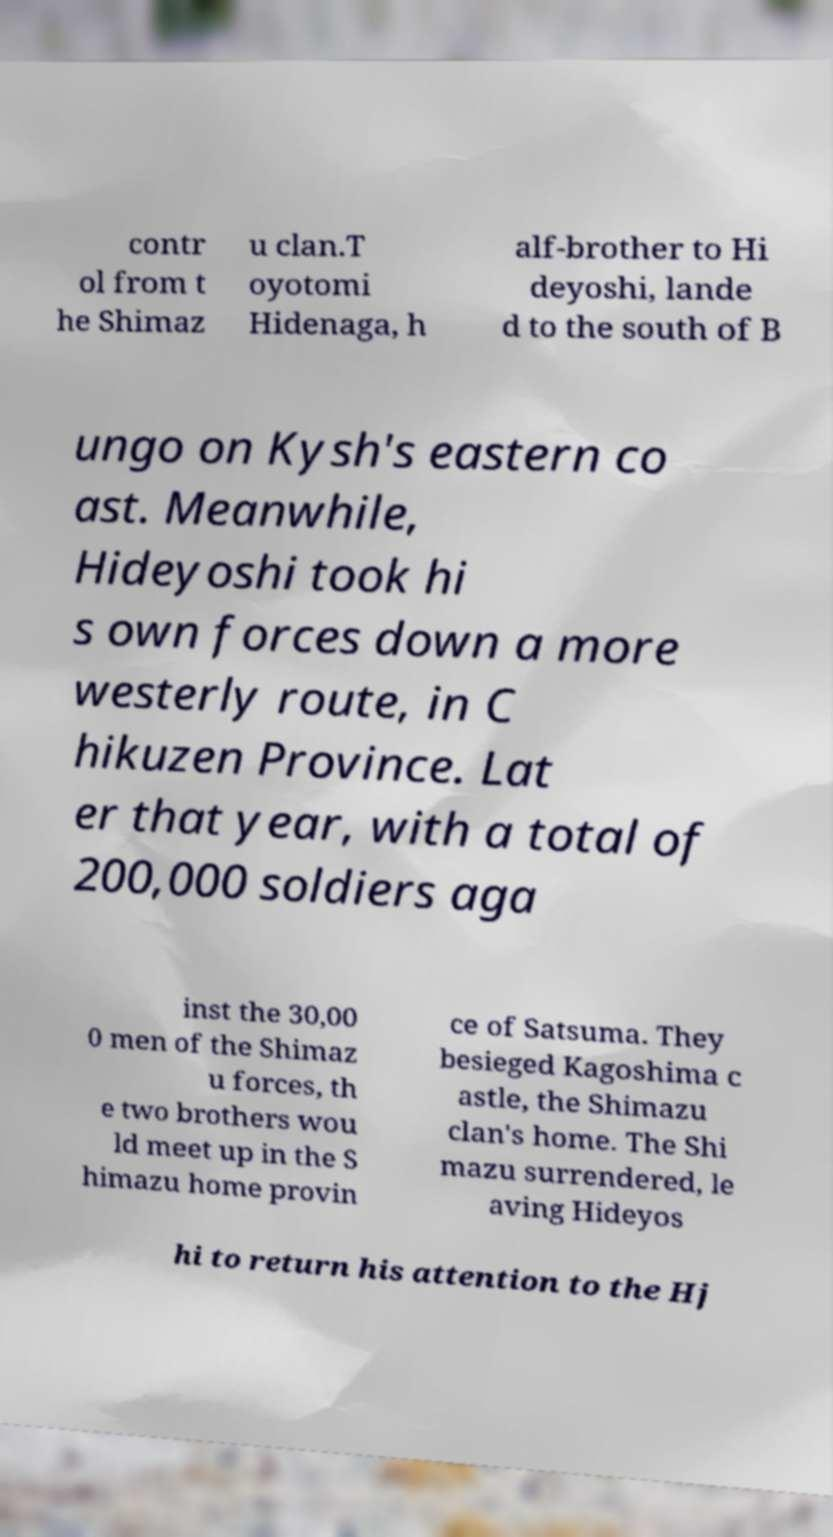For documentation purposes, I need the text within this image transcribed. Could you provide that? contr ol from t he Shimaz u clan.T oyotomi Hidenaga, h alf-brother to Hi deyoshi, lande d to the south of B ungo on Kysh's eastern co ast. Meanwhile, Hideyoshi took hi s own forces down a more westerly route, in C hikuzen Province. Lat er that year, with a total of 200,000 soldiers aga inst the 30,00 0 men of the Shimaz u forces, th e two brothers wou ld meet up in the S himazu home provin ce of Satsuma. They besieged Kagoshima c astle, the Shimazu clan's home. The Shi mazu surrendered, le aving Hideyos hi to return his attention to the Hj 